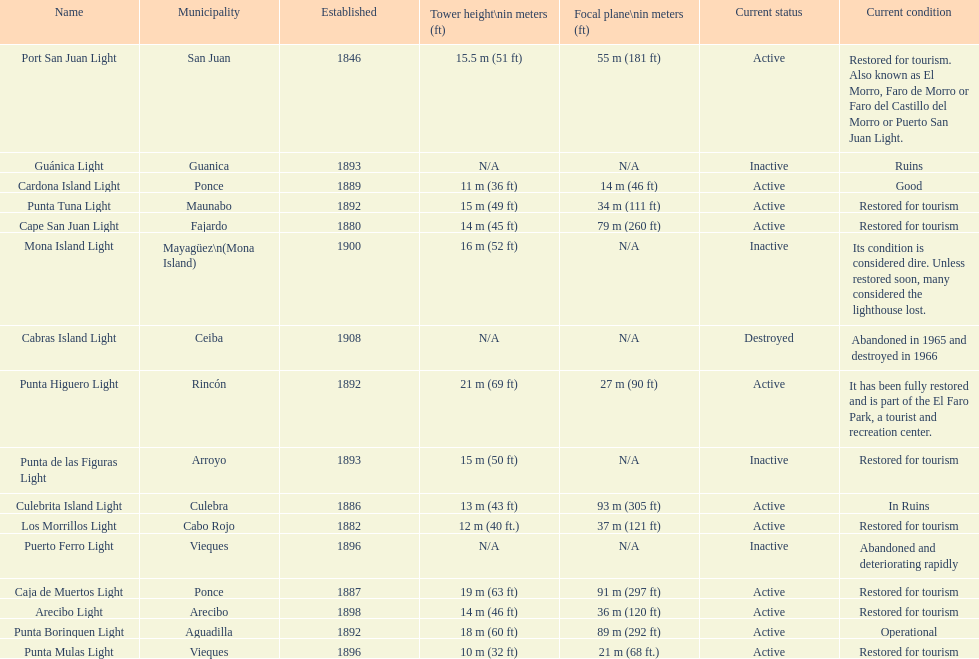Which municipality was the first to be established? San Juan. 